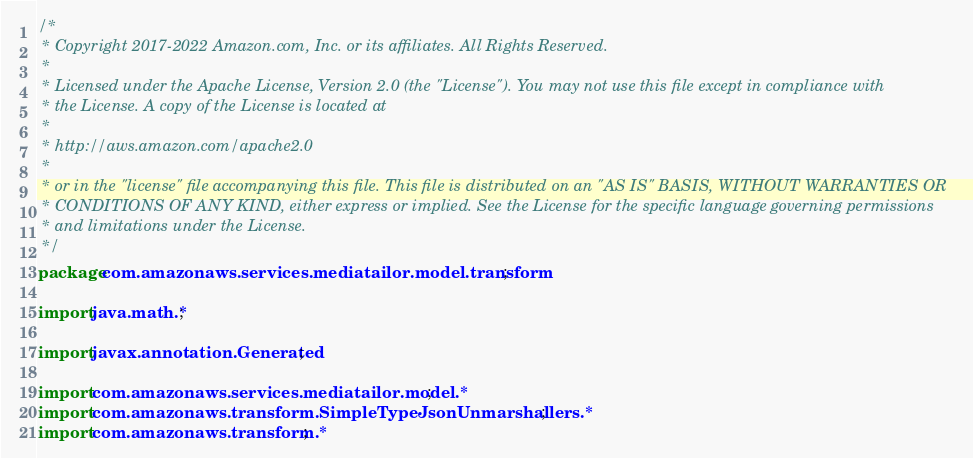Convert code to text. <code><loc_0><loc_0><loc_500><loc_500><_Java_>/*
 * Copyright 2017-2022 Amazon.com, Inc. or its affiliates. All Rights Reserved.
 * 
 * Licensed under the Apache License, Version 2.0 (the "License"). You may not use this file except in compliance with
 * the License. A copy of the License is located at
 * 
 * http://aws.amazon.com/apache2.0
 * 
 * or in the "license" file accompanying this file. This file is distributed on an "AS IS" BASIS, WITHOUT WARRANTIES OR
 * CONDITIONS OF ANY KIND, either express or implied. See the License for the specific language governing permissions
 * and limitations under the License.
 */
package com.amazonaws.services.mediatailor.model.transform;

import java.math.*;

import javax.annotation.Generated;

import com.amazonaws.services.mediatailor.model.*;
import com.amazonaws.transform.SimpleTypeJsonUnmarshallers.*;
import com.amazonaws.transform.*;
</code> 